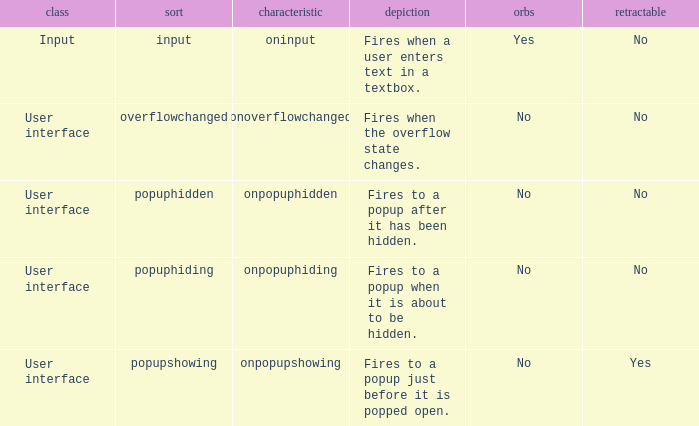 how many bubbles with category being input 1.0. 